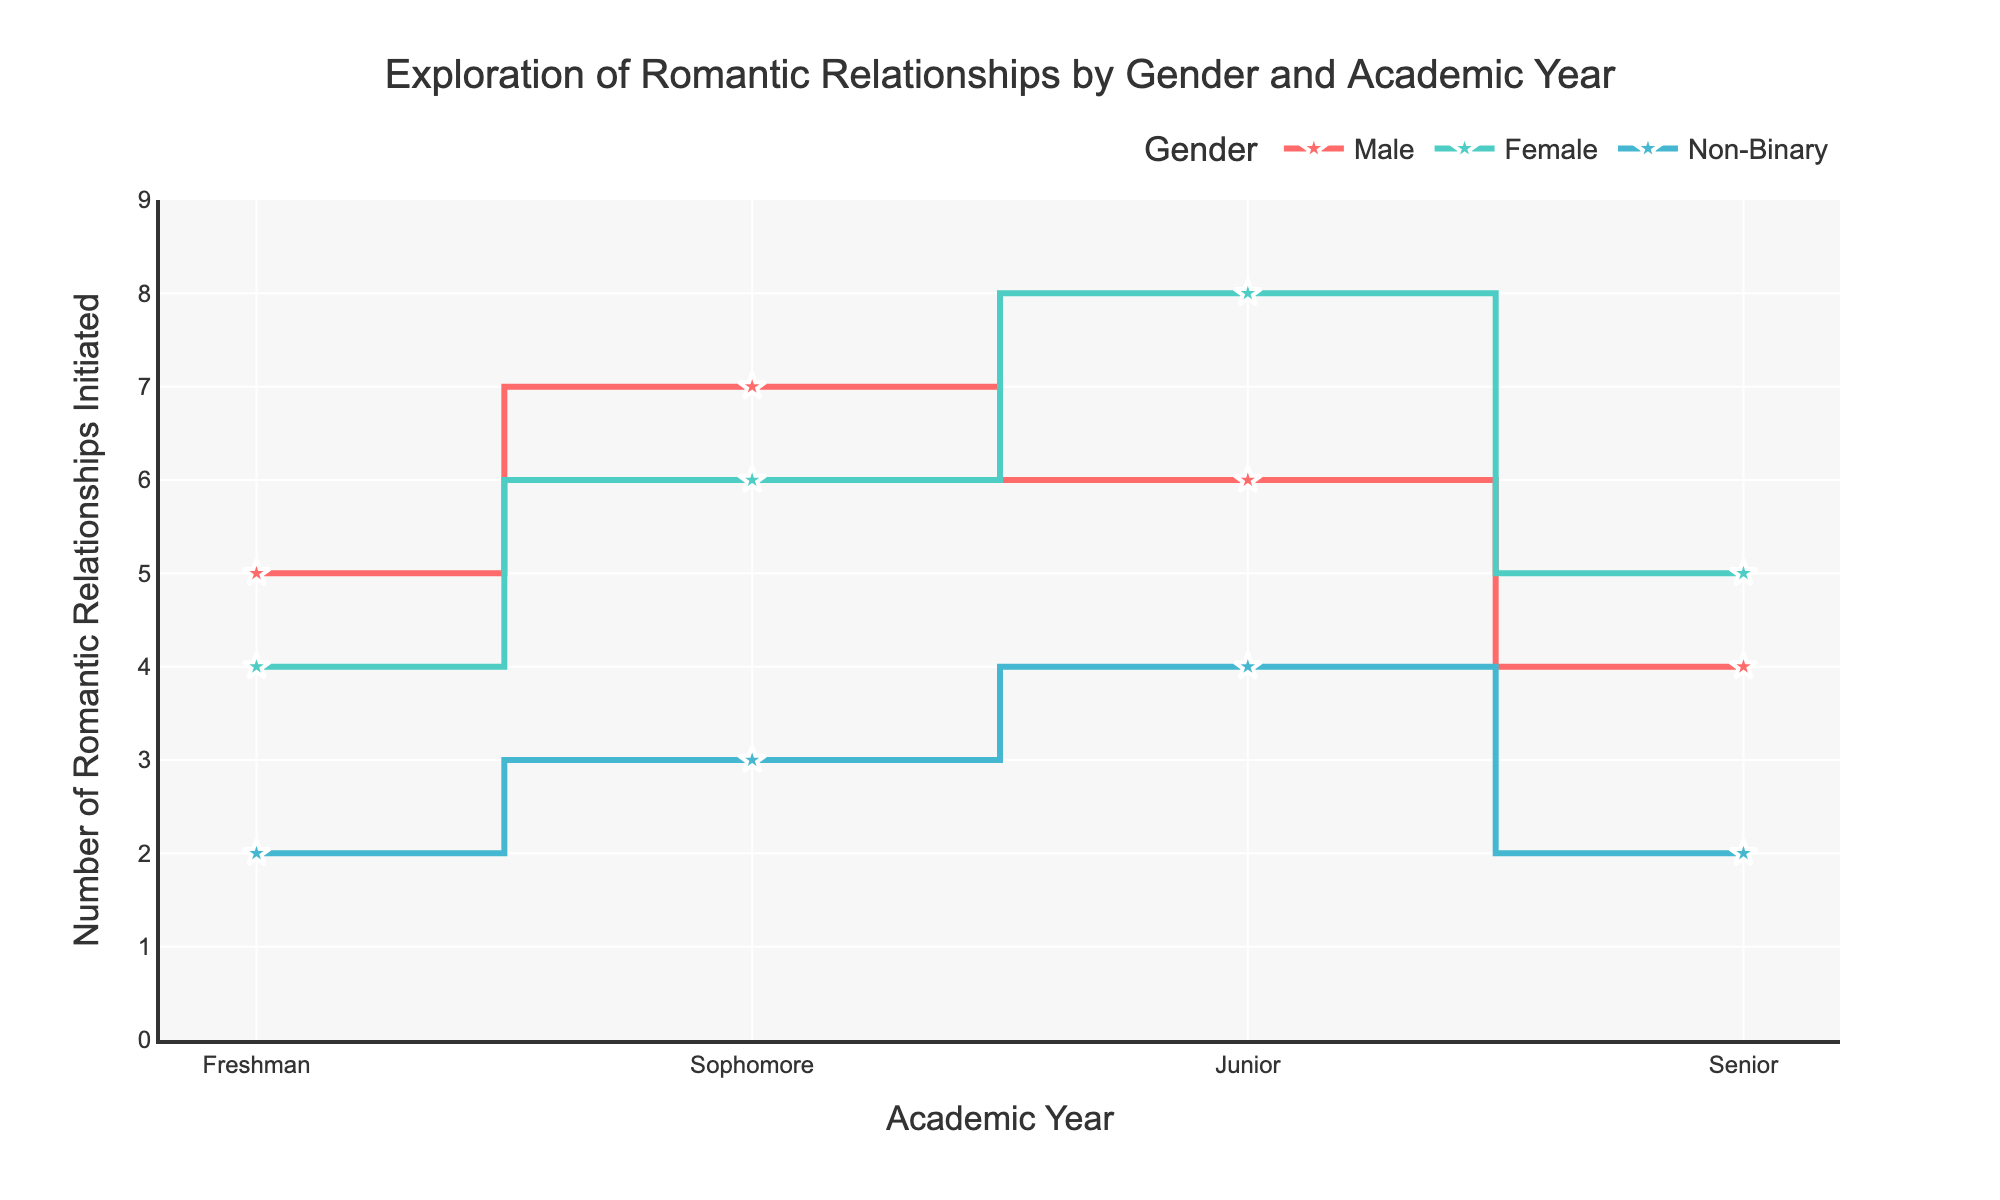What is the title of the plot? Look at the top of the plot for the text that describes its content.
Answer: Exploration of Romantic Relationships by Gender and Academic Year How many romantic relationships were initiated by Male students in their Junior year? Find the data point on the plot that corresponds to Male students in their Junior year and read the value.
Answer: 6 Which gender initiated the most romantic relationships in their Senior year? Compare the values for all genders in their Senior year and identify the highest one.
Answer: Female What is the total number of romantic relationships initiated by Non-Binary students across all academic years? Sum the values of romantic relationships initiated by Non-Binary students in each academic year (Freshman, Sophomore, Junior, Senior).
Answer: 11 Between which academic years do Female students show the greatest increase in the number of romantic relationships initiated? Compare the changes between consecutive academic years for Female students and identify the greatest increase. (Freshman to Sophomore: 4 to 6, Sophomore to Junior: 6 to 8, Junior to Senior: 8 to 5)
Answer: Sophomore to Junior Are there any academic years where the number of romantic relationships initiated is the same across any genders? Check each academic year and compare the values across genders to see if any of them are equal.
Answer: No Which gender shows a continuous decline in the number of romantic relationships initiated from Sophomore to Senior years? Look at the plot for trends between Sophomore to Senior years and identify if there's a continuous decline for any gender.
Answer: Male What is the average number of romantic relationships initiated by Female students throughout their academic years? Sum the values for Female students and then divide by the number of academic years (4 + 6 + 8 + 5) / 4 = 5.75
Answer: 5.75 Which academic year shows the highest variability in the number of romantic relationships initiated across genders? Compare the range of values (difference between maximum and minimum) for each academic year. Freshman: 5-2=3, Sophomore: 7-3=4, Junior: 8-4=4, Senior: 5-2=3
Answer: Sophomore and Junior 